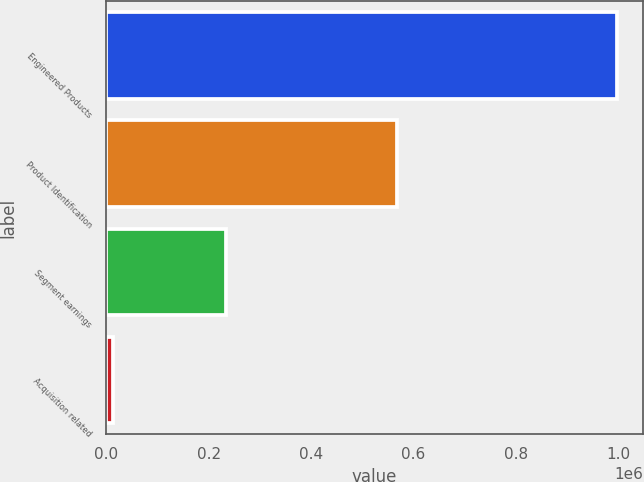Convert chart. <chart><loc_0><loc_0><loc_500><loc_500><bar_chart><fcel>Engineered Products<fcel>Product Identification<fcel>Segment earnings<fcel>Acquisition related<nl><fcel>998676<fcel>568303<fcel>234107<fcel>13193<nl></chart> 